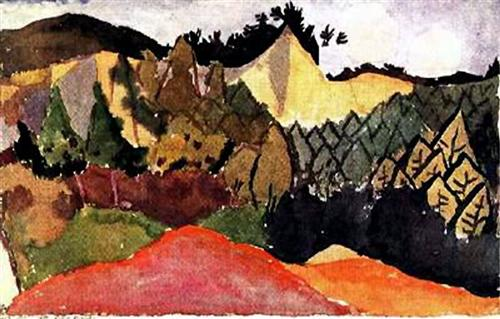Can you describe the main features of this image for me? The image showcases a dynamic and colorful landscape artwork. The composition presents a series of mountain peaks stretching into the horizon, with a valley unfolding in the lower portion of the scene. The painterly technique is energetic and expressive, employing quick and loose brushstrokes that capture the emotional essence rather than meticulous details. The color scheme is bold and unconventional, featuring reds, yellows, and greens, with strategic uses of black and white to introduce contrast and guide the viewer's eye through the terrain. Assuming the painting could be part of the Fauvism movement, it embraces the characteristics of heightened colors, simplicity of forms, and profound visual harmony, aiming to evoke an emotional response rather than a realistic representation. 